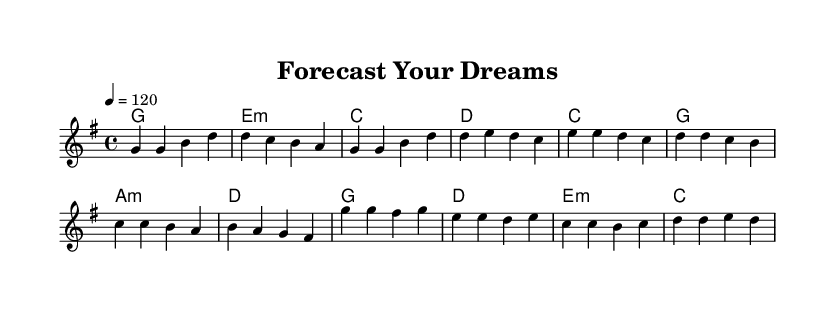What is the key signature of this music? The key signature is G major, indicated by one sharp (F#) in the key signature area at the beginning of the score.
Answer: G major What is the time signature of this piece? The time signature is 4/4, which means there are four beats in each measure, as shown in the time signature area at the beginning of the score.
Answer: 4/4 What is the tempo marking for the music? The tempo marking is 120 beats per minute, indicated by "4 = 120" in the tempo section.
Answer: 120 How many measures are in the chorus? The chorus contains four measures, which can be counted by observing the notes between the double bar lines labeled as "Chorus."
Answer: 4 What chords are used in the pre-chorus? The chords in the pre-chorus are C, G, A minor, and D, which can be found in the chord section for the pre-chorus.
Answer: C, G, A minor, D Which musical section contains the line "chasing dreams"? The line "chasing dreams" would likely appear in the chorus, as this section usually contains the central theme of an upbeat pop song about overcoming challenges.
Answer: Chorus How many notes are played in the first measure? There are four notes played in the first measure (G, G, B, D), which can be counted directly from the written notes in the measure.
Answer: 4 